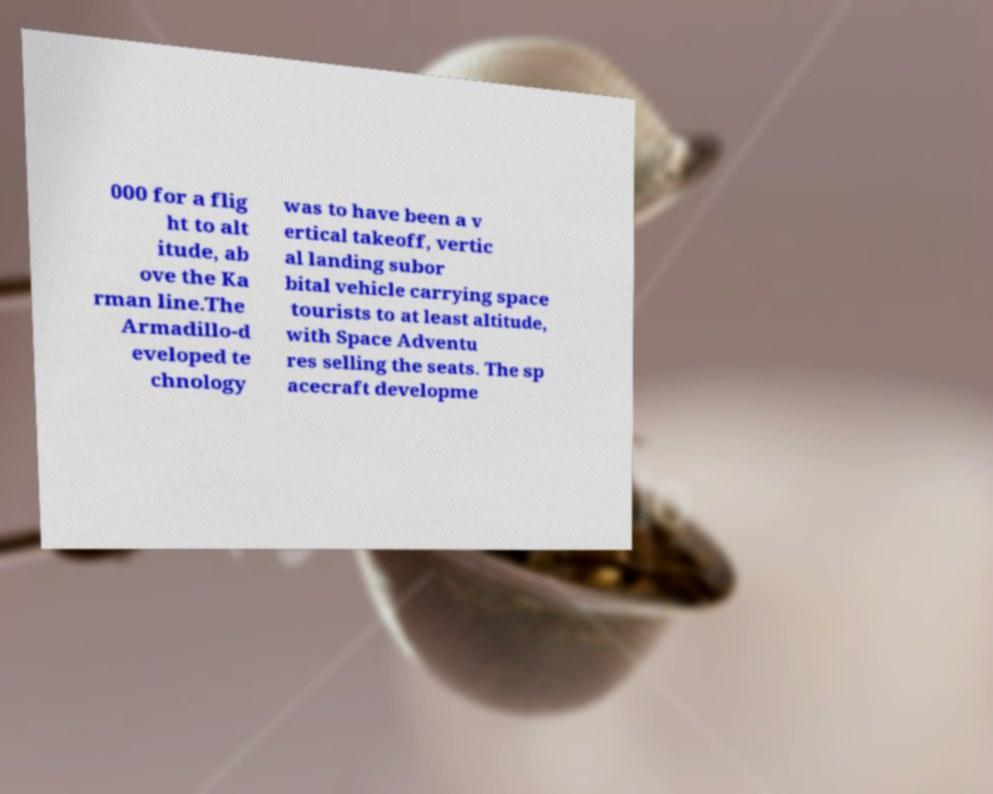For documentation purposes, I need the text within this image transcribed. Could you provide that? 000 for a flig ht to alt itude, ab ove the Ka rman line.The Armadillo-d eveloped te chnology was to have been a v ertical takeoff, vertic al landing subor bital vehicle carrying space tourists to at least altitude, with Space Adventu res selling the seats. The sp acecraft developme 